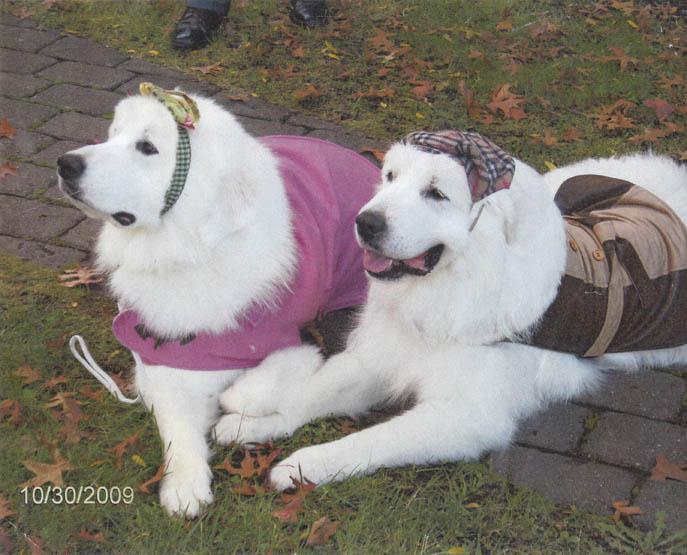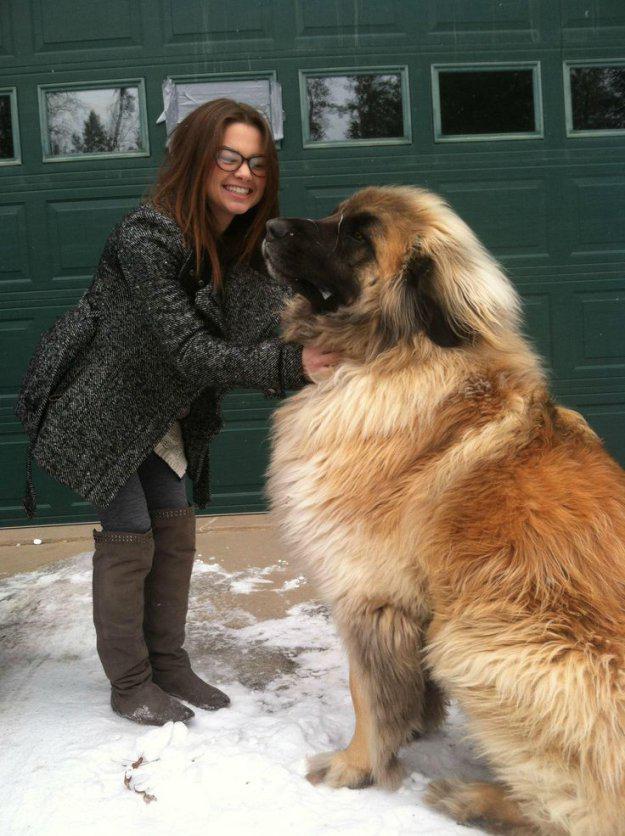The first image is the image on the left, the second image is the image on the right. Considering the images on both sides, is "Each image contains one fluffy young dog in a non-standing position, and all dogs are white with darker fur on their ears and around their eyes." valid? Answer yes or no. No. The first image is the image on the left, the second image is the image on the right. Examine the images to the left and right. Is the description "There is two dogs in the left image." accurate? Answer yes or no. Yes. 